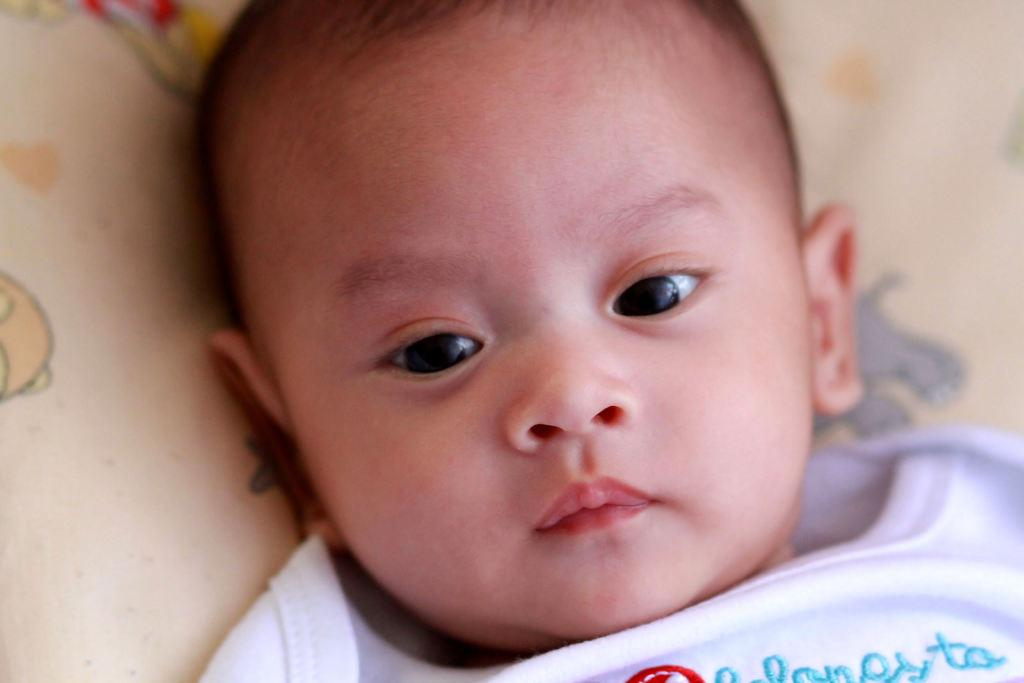What is the main subject of the picture? The main subject of the picture is a kid. What is the kid wearing in the image? The kid is wearing a white dress in the image. What is the kid lying on in the picture? The kid is lying on a pillow in the picture. What is the color of the pillow? The pillow is cream-colored. What type of dinosaur can be seen walking on the bridge in the image? There are no dinosaurs or bridges present in the image; it features a kid lying on a pillow. 